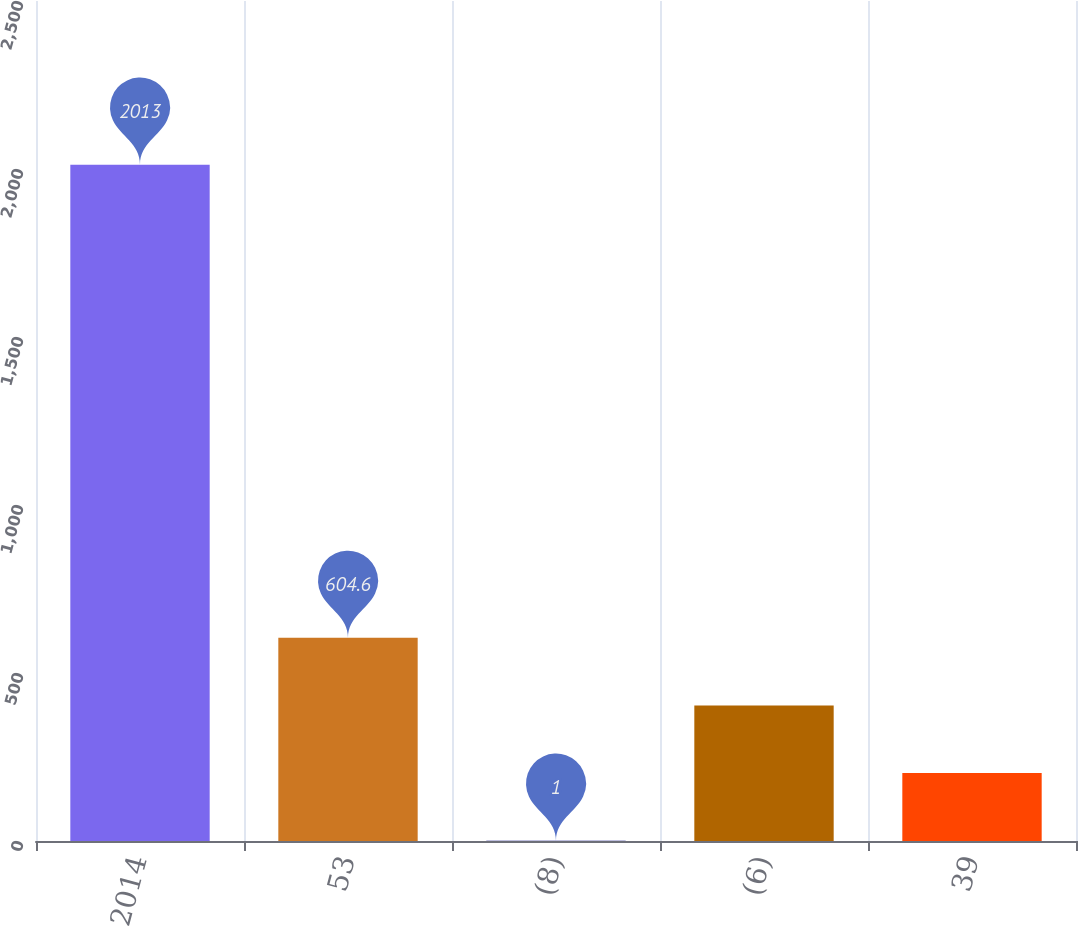Convert chart. <chart><loc_0><loc_0><loc_500><loc_500><bar_chart><fcel>2014<fcel>53<fcel>(8)<fcel>(6)<fcel>39<nl><fcel>2013<fcel>604.6<fcel>1<fcel>403.4<fcel>202.2<nl></chart> 